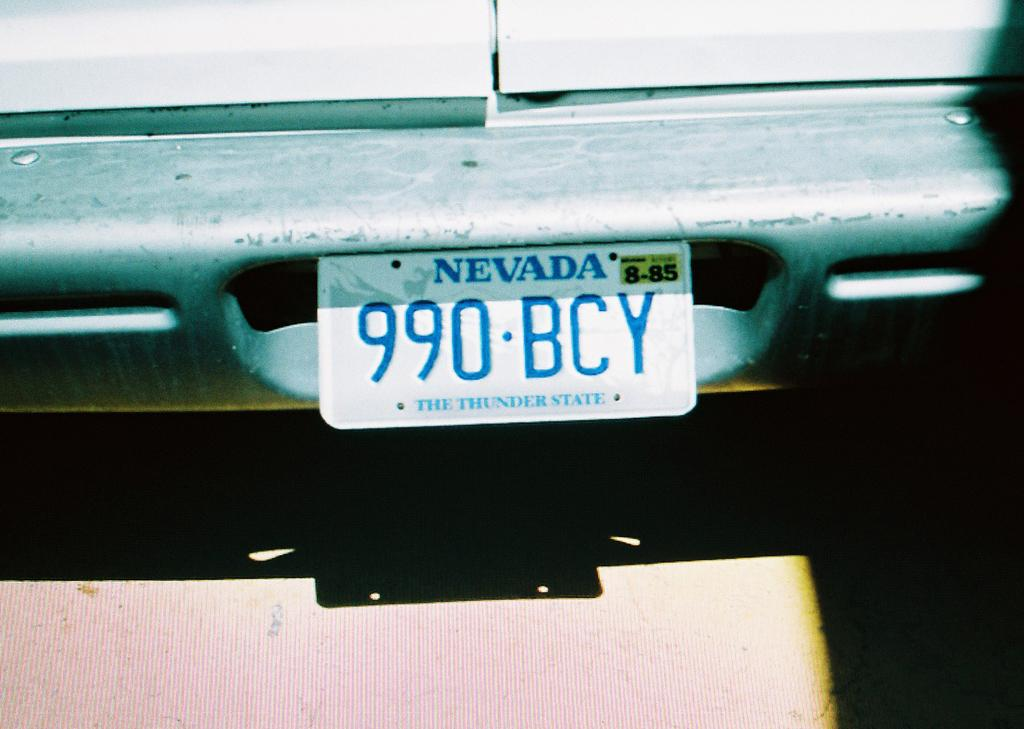<image>
Provide a brief description of the given image. A licenece plate for Nevada which starts with the numbers 990. 